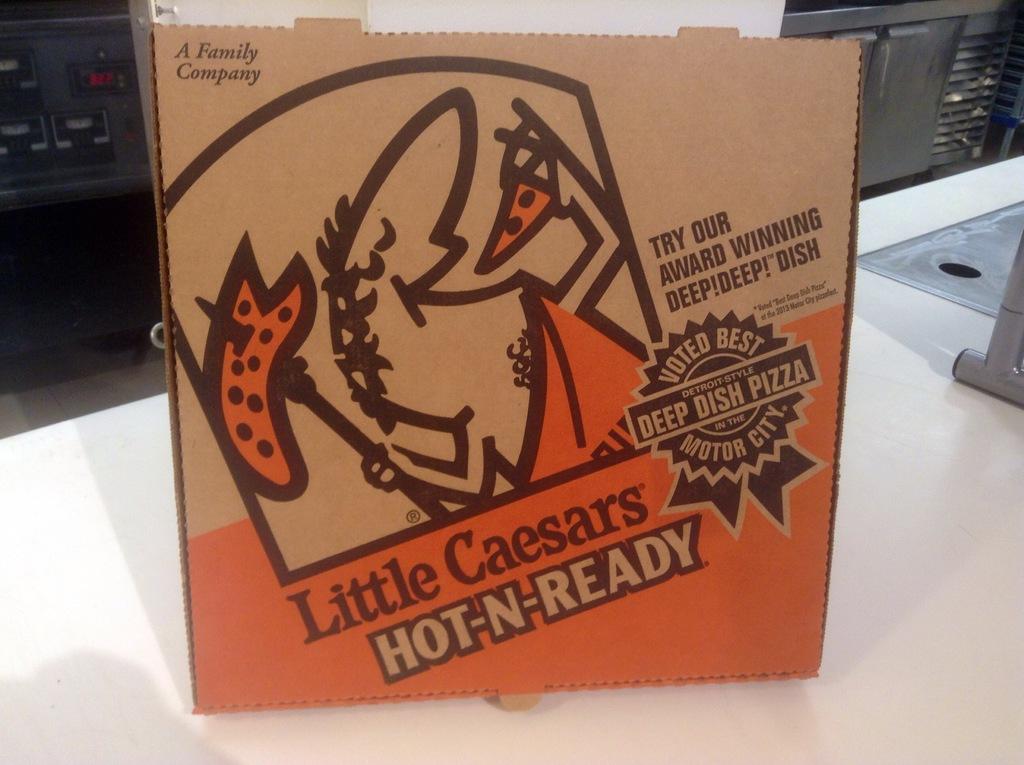What pizza brand is this?
Your answer should be compact. Little caesars. What is the brand of pizza being shown?
Make the answer very short. Little caesars. 